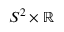Convert formula to latex. <formula><loc_0><loc_0><loc_500><loc_500>S ^ { 2 } \times \mathbb { R }</formula> 